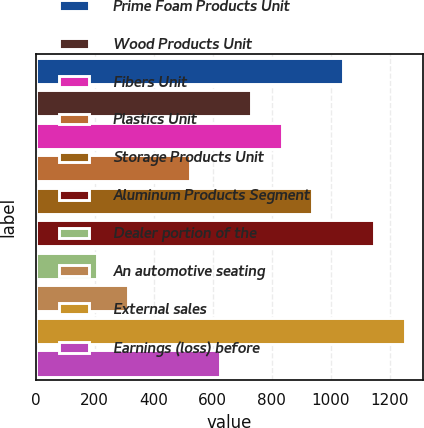Convert chart to OTSL. <chart><loc_0><loc_0><loc_500><loc_500><bar_chart><fcel>Prime Foam Products Unit<fcel>Wood Products Unit<fcel>Fibers Unit<fcel>Plastics Unit<fcel>Storage Products Unit<fcel>Aluminum Products Segment<fcel>Dealer portion of the<fcel>An automotive seating<fcel>External sales<fcel>Earnings (loss) before<nl><fcel>1041.8<fcel>729.53<fcel>833.62<fcel>521.35<fcel>937.71<fcel>1145.89<fcel>209.08<fcel>313.17<fcel>1249.98<fcel>625.44<nl></chart> 